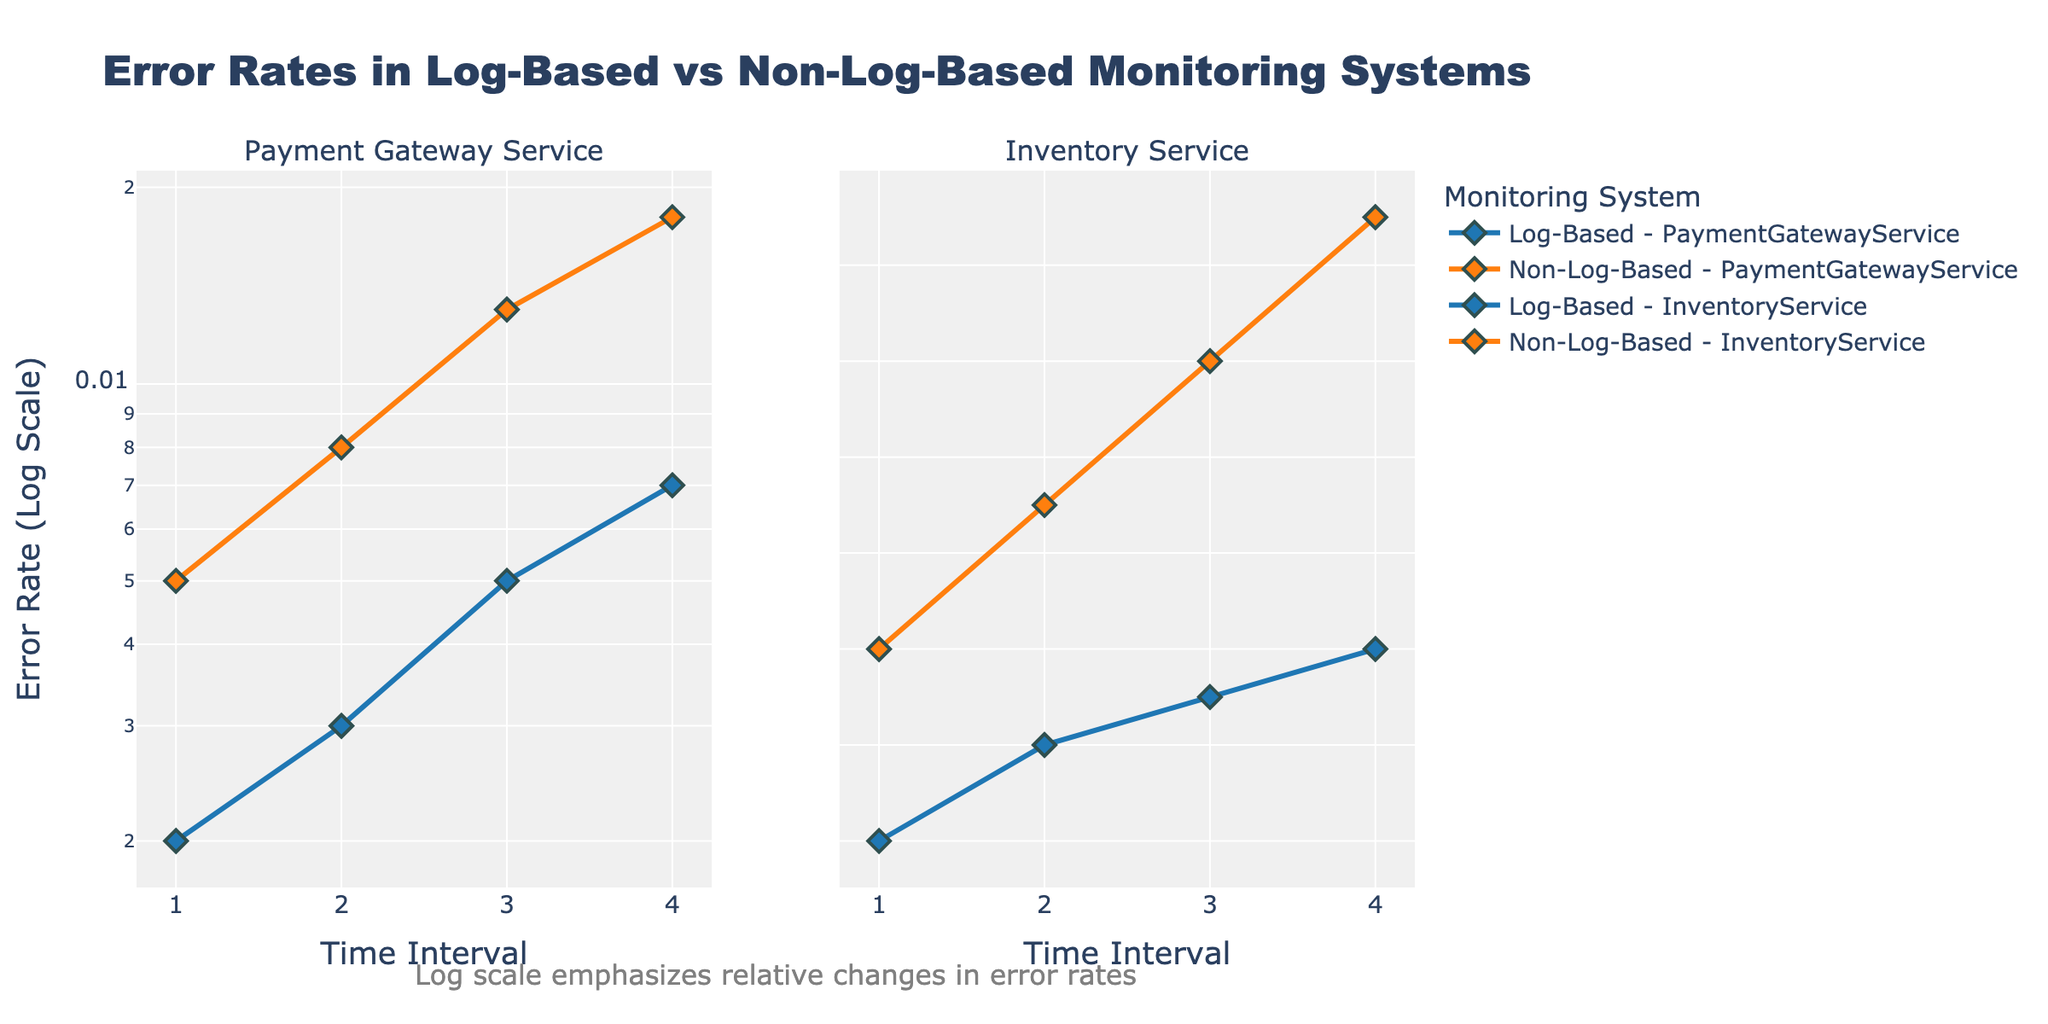How many subplots are there in the figure? The figure consists of two subplots. We can tell this because there are two separate titles for each subplot, one for "Payment Gateway Service" and one for "Inventory Service".
Answer: 2 What is the range of error rates in the Log-Based monitoring system for the Payment Gateway Service? The error rates for the Log-Based monitoring system for the Payment Gateway Service range from 0.002 to 0.007. These values are directly visible on the Y-axis listings for the corresponding line in the plot.
Answer: 0.002 to 0.007 Which monitoring system generally had higher error rates overall for the Payment Gateway Service? The Non-Log-Based monitoring system generally had higher error rates than the Log-Based system for the Payment Gateway Service. By comparing the two lines in the first subplot, it's clear that the Non-Log-Based system's error rates are consistently higher at all intervals.
Answer: Non-Log-Based During which interval did the Inventory Service experience an error rate of 0.006 in a Non-Log-Based monitoring system? The Inventory Service experienced an error rate of 0.006 in the Non-Log-Based monitoring system during the third interval. This is evident from the data points plotted in the second subplot.
Answer: Interval 3 What can be inferred about the trend in error rates over the 4 intervals for the Non-Log-Based monitoring system in the Payment Gateway Service? Over the 4 intervals, the error rates for the Non-Log-Based monitoring system in the Payment Gateway Service consistently increased. This is indicated by the upward trend of the line in the first subplot for Non-Log-Based monitoring.
Answer: Consistently increased How does the change in error rates from interval 1 to 4 for the Log-Based versus Non-Log-Based system compare for the Inventory Service? For the Inventory Service, the error rate in the Log-Based system changed from 0.001 to 0.003 (increase of 0.002), whereas for the Non-Log-Based system, it changed from 0.003 to 0.0075 (increase of 0.0045). This shows that the Non-Log-Based system had a greater increase in error rates over the intervals.
Answer: Greater increase in Non-Log-Based Which subplot demonstrates that the log scale emphasizes relative changes in error rates? The annotation under the entire figure states that the log scale emphasizes relative changes in error rates, making this applicable to both subplots collectively.
Answer: Both subplots Between the Payment Gateway Service and Inventory Service in the Log-Based monitoring system, which one had relatively lower error rates at the 4th interval? Comparing the data points at the 4th interval, the Payment Gateway Service had an error rate of 0.007, whereas the Inventory Service had an error rate of 0.003 in the Log-Based monitoring system. Thus, the Inventory Service had relatively lower error rates at the 4th interval.
Answer: Inventory Service What is the average error rate across all intervals in the Log-Based monitoring system for the Inventory Service? To find the average error rate across all intervals in the Log-Based monitoring system for the Inventory Service, we sum the error rates from all intervals (0.001 + 0.002 + 0.0025 + 0.003) which equals 0.0085. Dividing this sum by the number of intervals (4) gives the average error rate of 0.002125.
Answer: 0.002125 